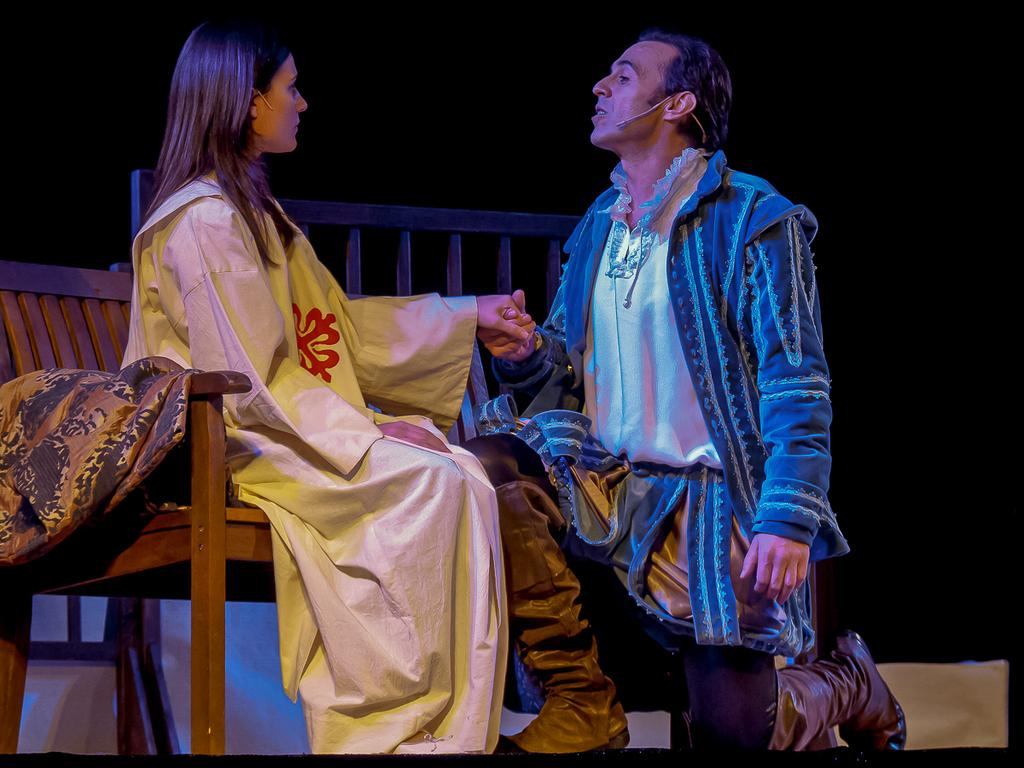What is the woman doing in the image? The woman is sitting on a bench in the image. Where is the woman located in the image? The woman is on the left side of the image. What is the man doing in the image? The man is in a squatting position in the image. What color is the man's coat? The man is wearing a blue coat. What color are the man's trousers? The man is wearing black trousers. What type of needle is the man using to sew in the image? There is no needle present in the image; the man is not sewing. 